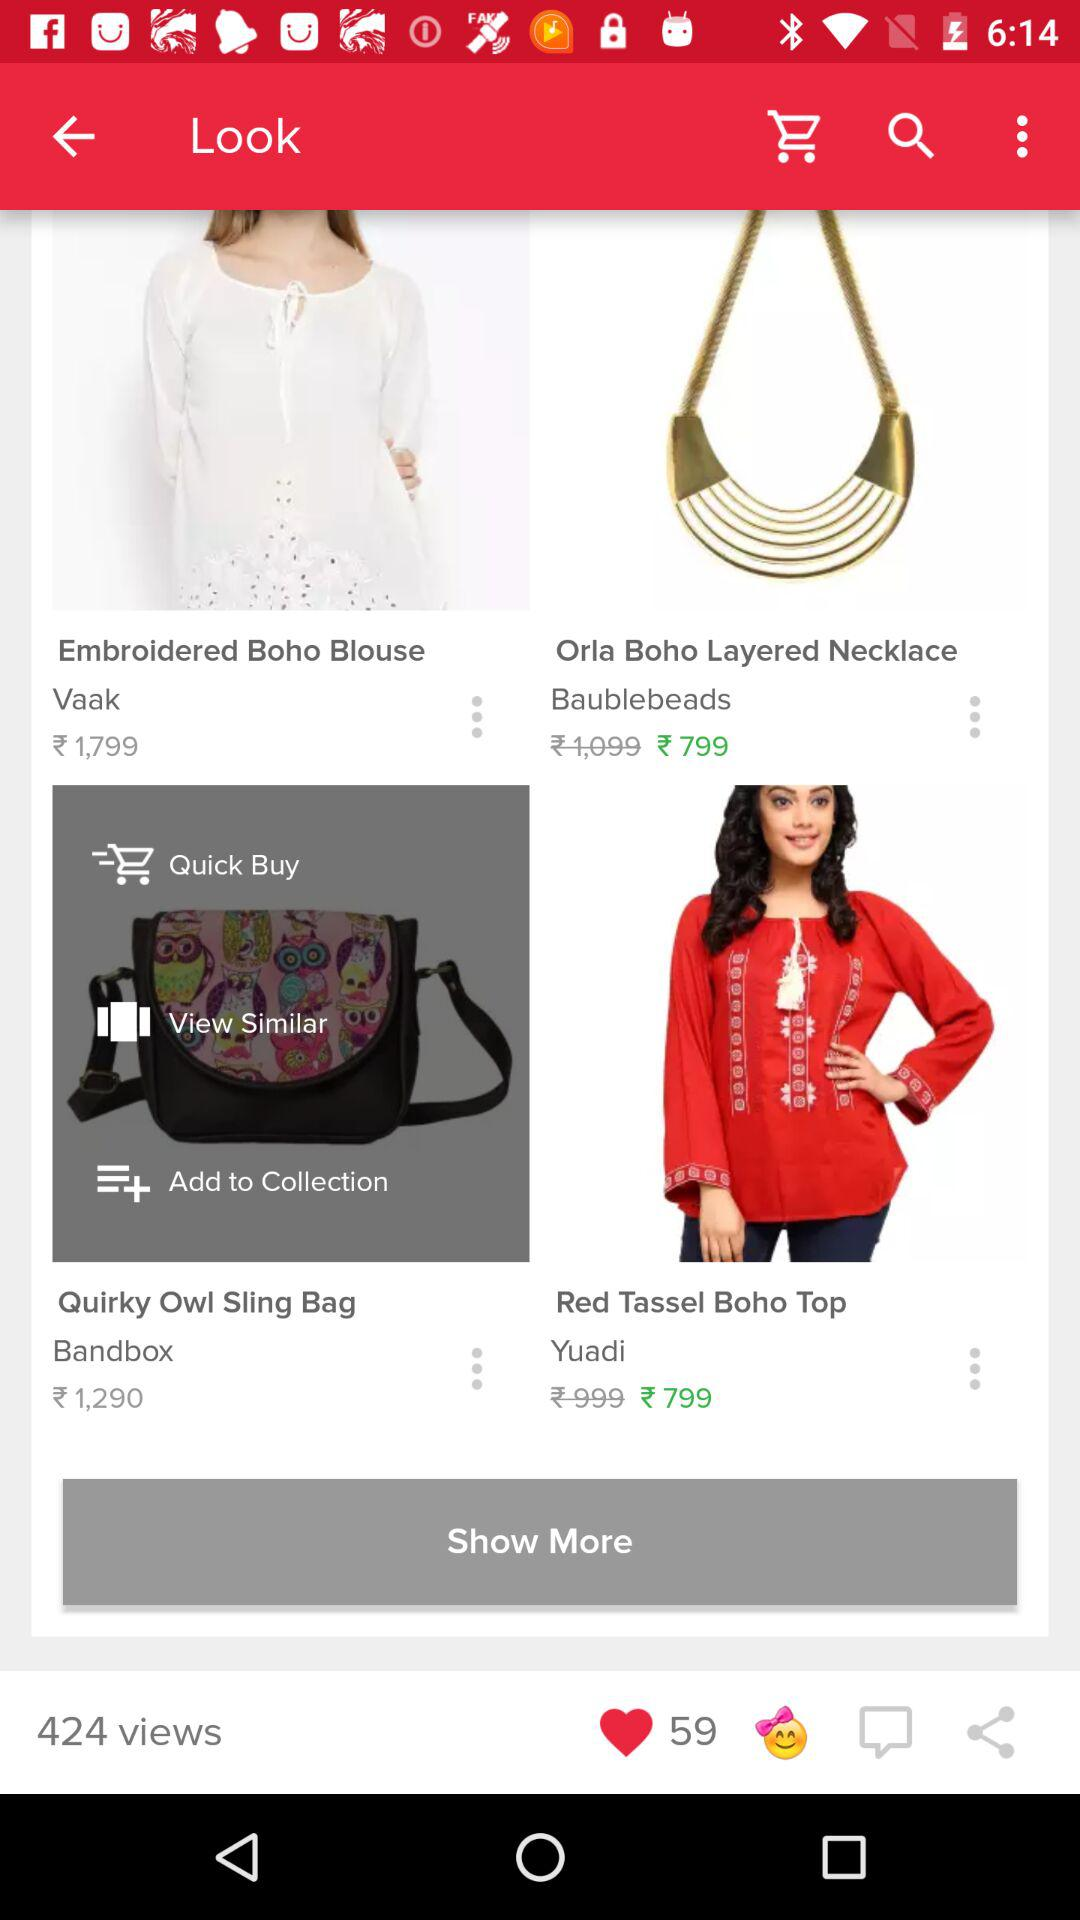How many likes in total are there? There are 59 likes in total. 